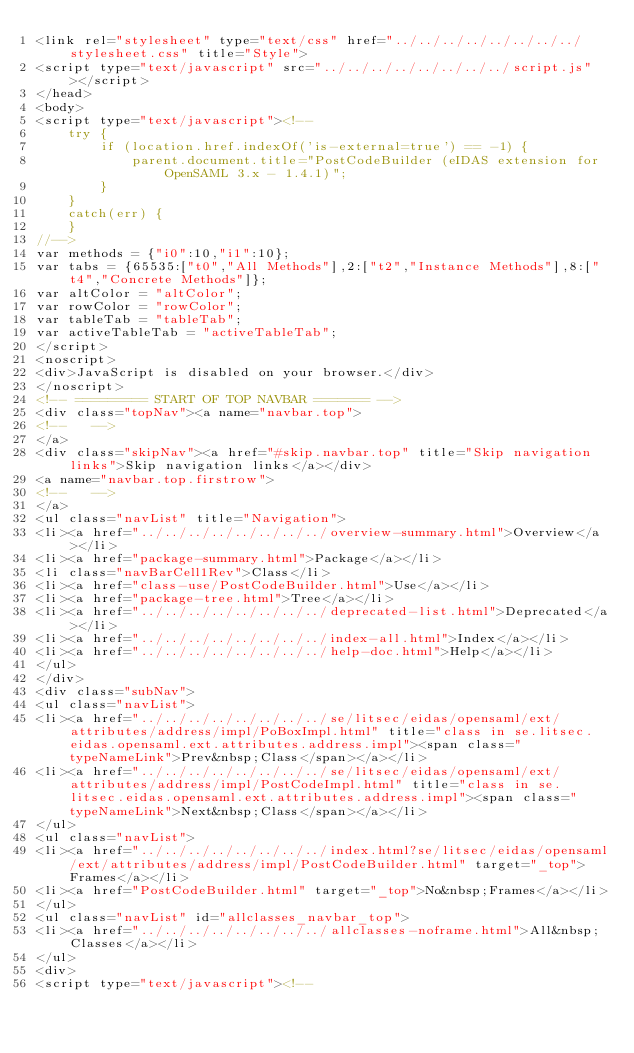Convert code to text. <code><loc_0><loc_0><loc_500><loc_500><_HTML_><link rel="stylesheet" type="text/css" href="../../../../../../../../stylesheet.css" title="Style">
<script type="text/javascript" src="../../../../../../../../script.js"></script>
</head>
<body>
<script type="text/javascript"><!--
    try {
        if (location.href.indexOf('is-external=true') == -1) {
            parent.document.title="PostCodeBuilder (eIDAS extension for OpenSAML 3.x - 1.4.1)";
        }
    }
    catch(err) {
    }
//-->
var methods = {"i0":10,"i1":10};
var tabs = {65535:["t0","All Methods"],2:["t2","Instance Methods"],8:["t4","Concrete Methods"]};
var altColor = "altColor";
var rowColor = "rowColor";
var tableTab = "tableTab";
var activeTableTab = "activeTableTab";
</script>
<noscript>
<div>JavaScript is disabled on your browser.</div>
</noscript>
<!-- ========= START OF TOP NAVBAR ======= -->
<div class="topNav"><a name="navbar.top">
<!--   -->
</a>
<div class="skipNav"><a href="#skip.navbar.top" title="Skip navigation links">Skip navigation links</a></div>
<a name="navbar.top.firstrow">
<!--   -->
</a>
<ul class="navList" title="Navigation">
<li><a href="../../../../../../../../overview-summary.html">Overview</a></li>
<li><a href="package-summary.html">Package</a></li>
<li class="navBarCell1Rev">Class</li>
<li><a href="class-use/PostCodeBuilder.html">Use</a></li>
<li><a href="package-tree.html">Tree</a></li>
<li><a href="../../../../../../../../deprecated-list.html">Deprecated</a></li>
<li><a href="../../../../../../../../index-all.html">Index</a></li>
<li><a href="../../../../../../../../help-doc.html">Help</a></li>
</ul>
</div>
<div class="subNav">
<ul class="navList">
<li><a href="../../../../../../../../se/litsec/eidas/opensaml/ext/attributes/address/impl/PoBoxImpl.html" title="class in se.litsec.eidas.opensaml.ext.attributes.address.impl"><span class="typeNameLink">Prev&nbsp;Class</span></a></li>
<li><a href="../../../../../../../../se/litsec/eidas/opensaml/ext/attributes/address/impl/PostCodeImpl.html" title="class in se.litsec.eidas.opensaml.ext.attributes.address.impl"><span class="typeNameLink">Next&nbsp;Class</span></a></li>
</ul>
<ul class="navList">
<li><a href="../../../../../../../../index.html?se/litsec/eidas/opensaml/ext/attributes/address/impl/PostCodeBuilder.html" target="_top">Frames</a></li>
<li><a href="PostCodeBuilder.html" target="_top">No&nbsp;Frames</a></li>
</ul>
<ul class="navList" id="allclasses_navbar_top">
<li><a href="../../../../../../../../allclasses-noframe.html">All&nbsp;Classes</a></li>
</ul>
<div>
<script type="text/javascript"><!--</code> 